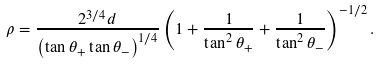Convert formula to latex. <formula><loc_0><loc_0><loc_500><loc_500>\rho = \frac { 2 ^ { 3 / 4 } d } { \left ( \tan \theta _ { + } \tan \theta _ { - } \right ) ^ { 1 / 4 } } \left ( 1 + \frac { 1 } { \tan ^ { 2 } \theta _ { + } } + \frac { 1 } { \tan ^ { 2 } \theta _ { - } } \right ) ^ { - 1 / 2 } .</formula> 